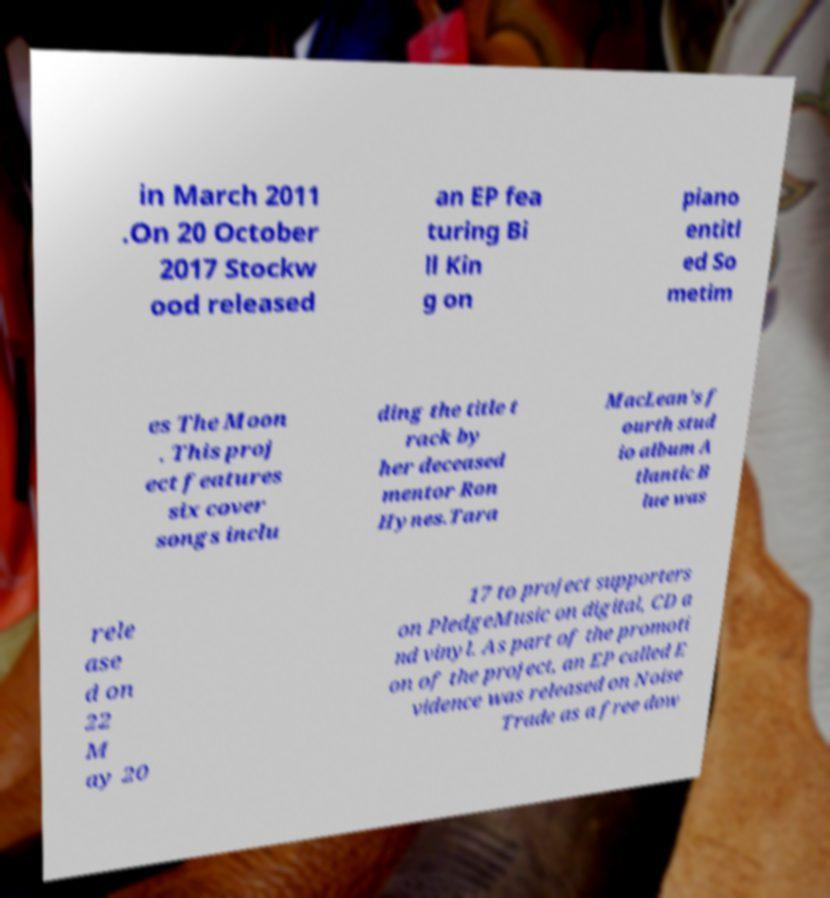Please read and relay the text visible in this image. What does it say? in March 2011 .On 20 October 2017 Stockw ood released an EP fea turing Bi ll Kin g on piano entitl ed So metim es The Moon . This proj ect features six cover songs inclu ding the title t rack by her deceased mentor Ron Hynes.Tara MacLean's f ourth stud io album A tlantic B lue was rele ase d on 22 M ay 20 17 to project supporters on PledgeMusic on digital, CD a nd vinyl. As part of the promoti on of the project, an EP called E vidence was released on Noise Trade as a free dow 